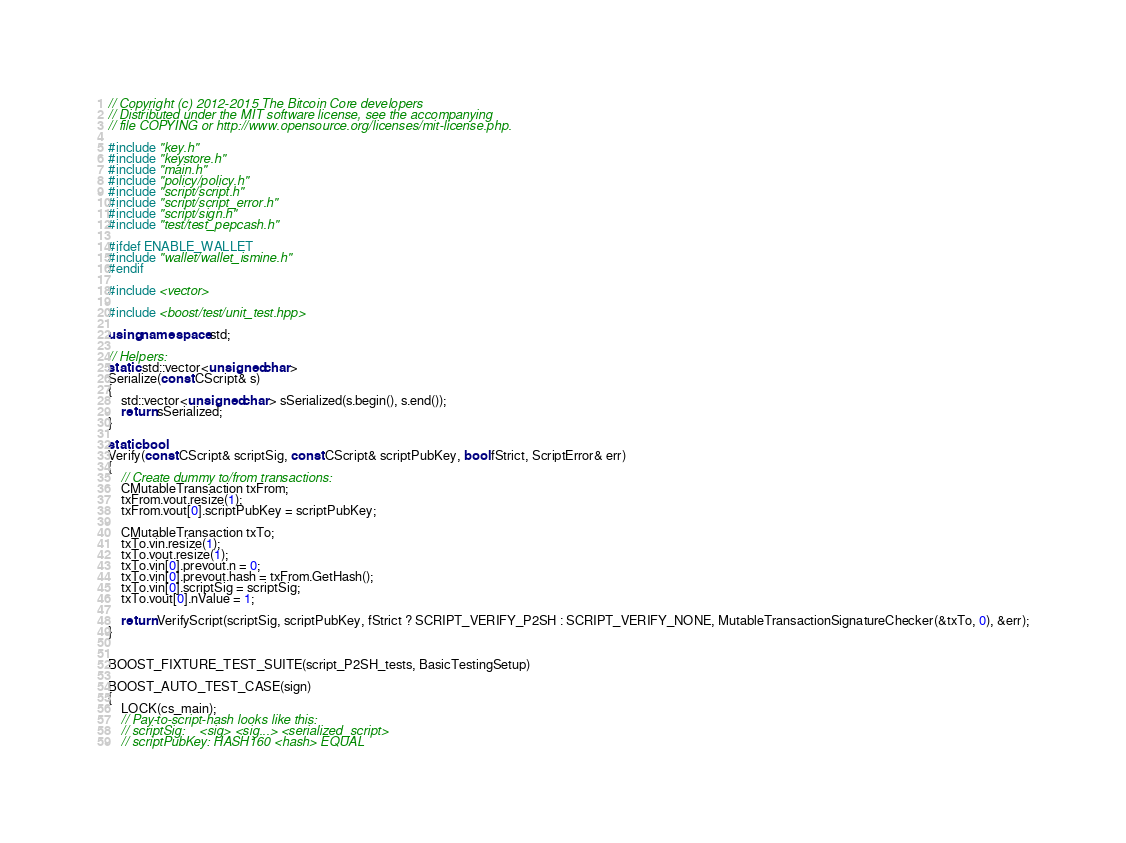Convert code to text. <code><loc_0><loc_0><loc_500><loc_500><_C++_>// Copyright (c) 2012-2015 The Bitcoin Core developers
// Distributed under the MIT software license, see the accompanying
// file COPYING or http://www.opensource.org/licenses/mit-license.php.

#include "key.h"
#include "keystore.h"
#include "main.h"
#include "policy/policy.h"
#include "script/script.h"
#include "script/script_error.h"
#include "script/sign.h"
#include "test/test_pepcash.h"

#ifdef ENABLE_WALLET
#include "wallet/wallet_ismine.h"
#endif

#include <vector>

#include <boost/test/unit_test.hpp>

using namespace std;

// Helpers:
static std::vector<unsigned char>
Serialize(const CScript& s)
{
    std::vector<unsigned char> sSerialized(s.begin(), s.end());
    return sSerialized;
}

static bool
Verify(const CScript& scriptSig, const CScript& scriptPubKey, bool fStrict, ScriptError& err)
{
    // Create dummy to/from transactions:
    CMutableTransaction txFrom;
    txFrom.vout.resize(1);
    txFrom.vout[0].scriptPubKey = scriptPubKey;

    CMutableTransaction txTo;
    txTo.vin.resize(1);
    txTo.vout.resize(1);
    txTo.vin[0].prevout.n = 0;
    txTo.vin[0].prevout.hash = txFrom.GetHash();
    txTo.vin[0].scriptSig = scriptSig;
    txTo.vout[0].nValue = 1;

    return VerifyScript(scriptSig, scriptPubKey, fStrict ? SCRIPT_VERIFY_P2SH : SCRIPT_VERIFY_NONE, MutableTransactionSignatureChecker(&txTo, 0), &err);
}


BOOST_FIXTURE_TEST_SUITE(script_P2SH_tests, BasicTestingSetup)

BOOST_AUTO_TEST_CASE(sign)
{
    LOCK(cs_main);
    // Pay-to-script-hash looks like this:
    // scriptSig:    <sig> <sig...> <serialized_script>
    // scriptPubKey: HASH160 <hash> EQUAL
</code> 